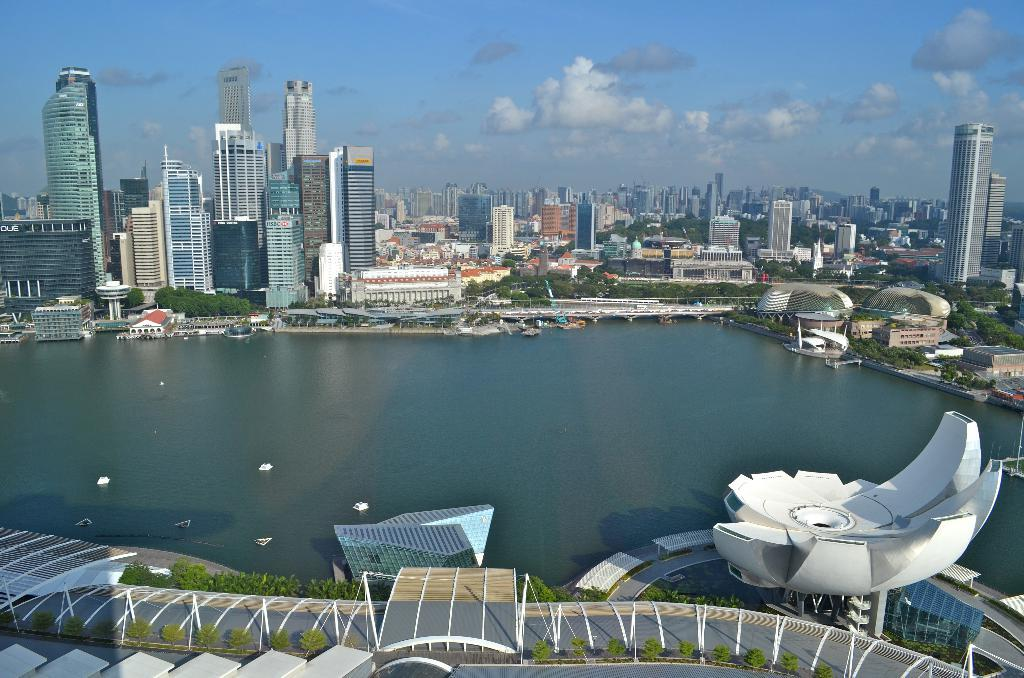What is located above the water and plants in the image? There are white objects above the water and plants in the image. What can be seen in the background of the image? There are buildings, trees, and the sky visible in the background of the image. Are there any clouds in the sky? Yes, clouds are present in the sky. Reasoning: Let's think step by following the guidelines to produce the conversation. We start by identifying the main subjects and objects in the image based on the provided facts. We then formulate questions that focus on the location and characteristics of these subjects and objects, ensuring that each question can be answered definitively with the information given. We avoid yes/no questions and ensure that the language is simple and clear. Absurd Question/Answer: What type of oven can be seen in the image? There is no oven present in the image. How many daughters are visible in the image? There are no people, let alone daughters, visible in the image. What type of selection is being made in the image? There is no indication of a selection being made in the image. How many daughters are visible in the image? There are no people, let alone daughters, visible in the image. 